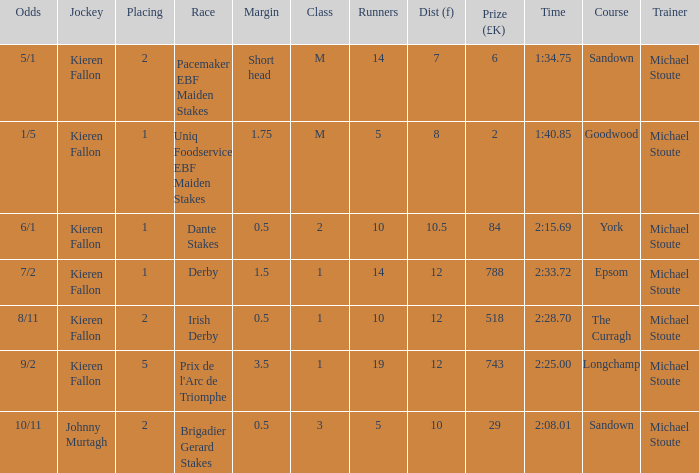Name the runners for longchamp 19.0. 